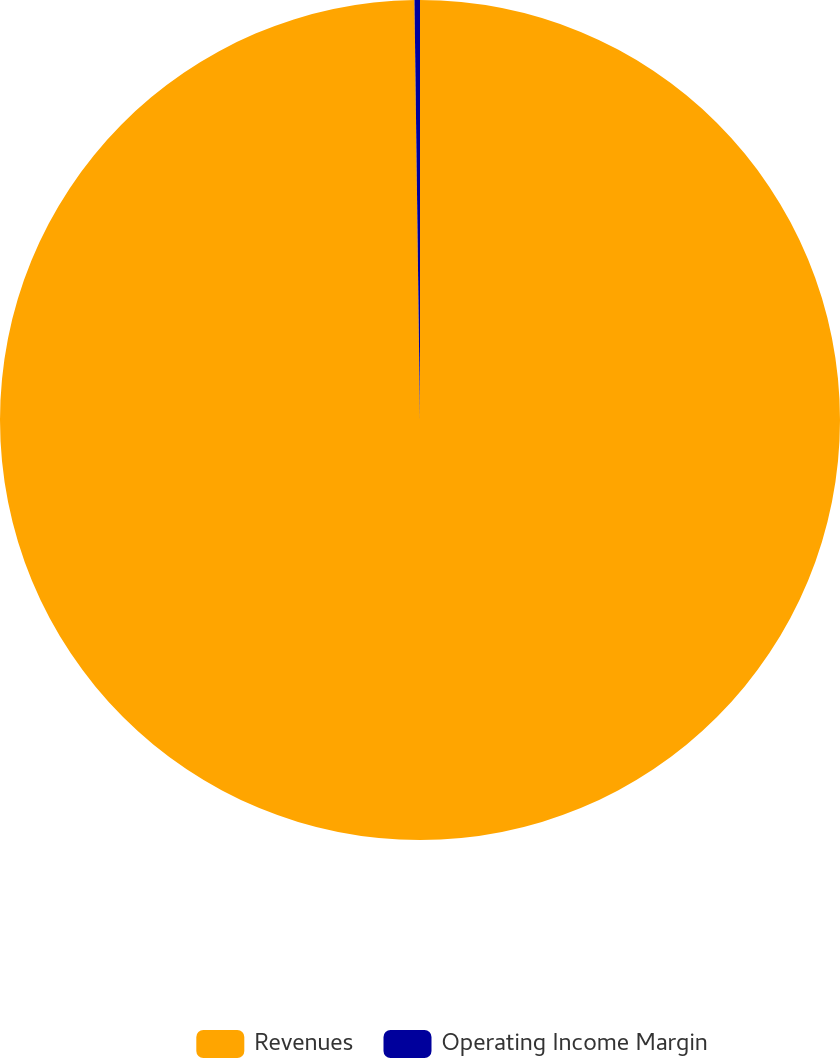<chart> <loc_0><loc_0><loc_500><loc_500><pie_chart><fcel>Revenues<fcel>Operating Income Margin<nl><fcel>99.79%<fcel>0.21%<nl></chart> 